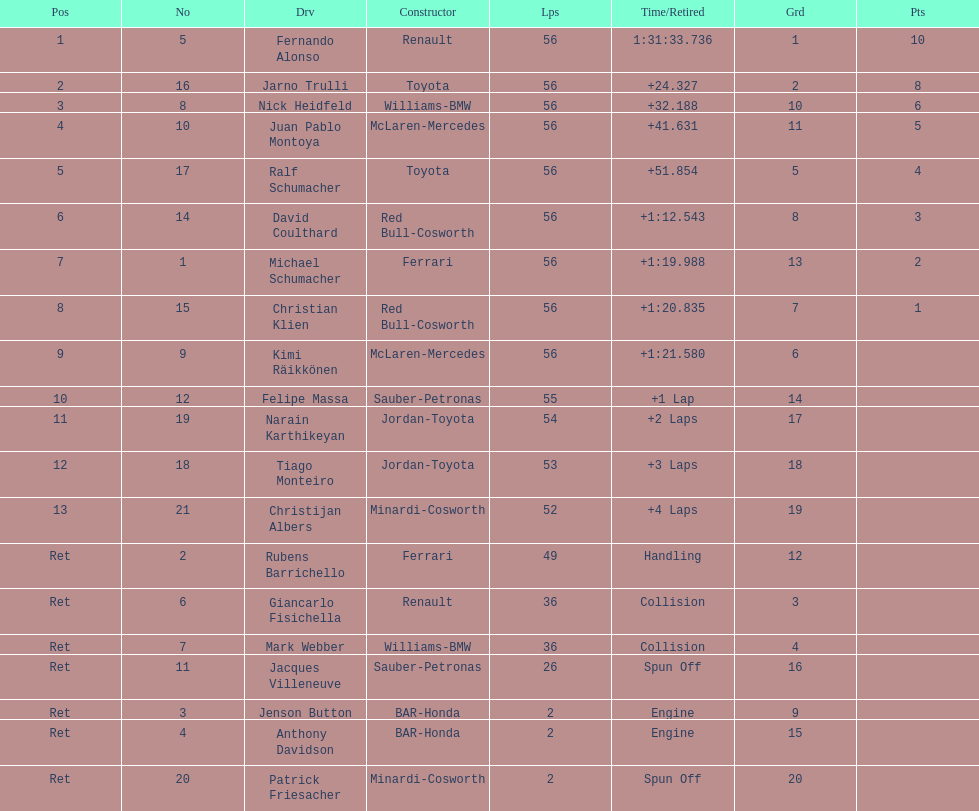What were the total number of laps completed by the 1st position winner? 56. 